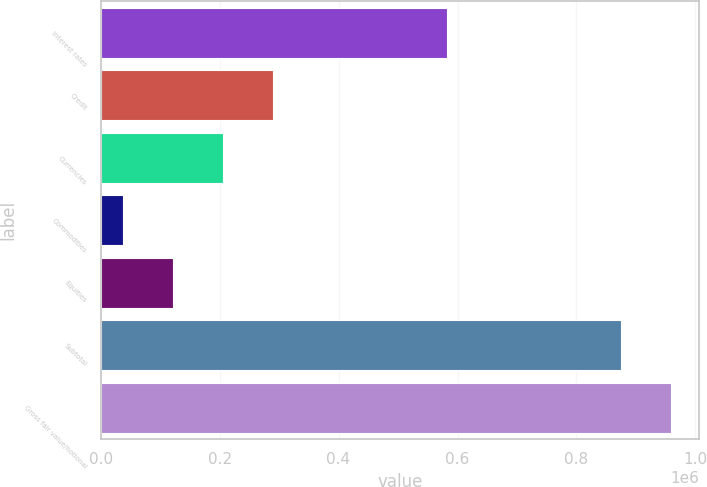Convert chart. <chart><loc_0><loc_0><loc_500><loc_500><bar_chart><fcel>Interest rates<fcel>Credit<fcel>Currencies<fcel>Commodities<fcel>Equities<fcel>Subtotal<fcel>Gross fair value/notional<nl><fcel>582608<fcel>289140<fcel>205443<fcel>38050<fcel>121746<fcel>874981<fcel>958678<nl></chart> 